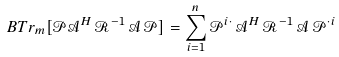<formula> <loc_0><loc_0><loc_500><loc_500>B T r _ { m } [ \mathcal { P A } ^ { H } \, \mathcal { R } ^ { - 1 } \, \mathcal { A \, P } ] = \sum _ { i = 1 } ^ { n } \mathcal { P } ^ { i \cdot } \, \mathcal { A } ^ { H } \, \mathcal { R } ^ { - 1 } \, \mathcal { A \, P } ^ { \cdot i }</formula> 